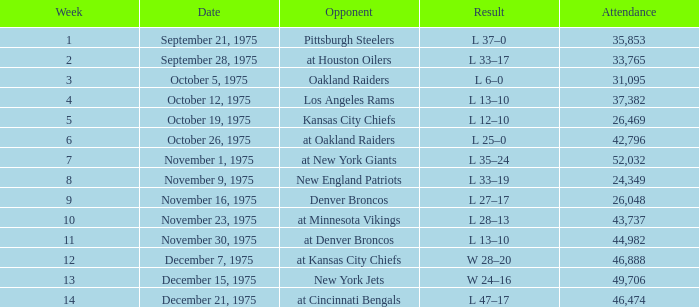What is the maximum week when the opposition was kansas city chiefs, with an attendance surpassing 26,469? None. 